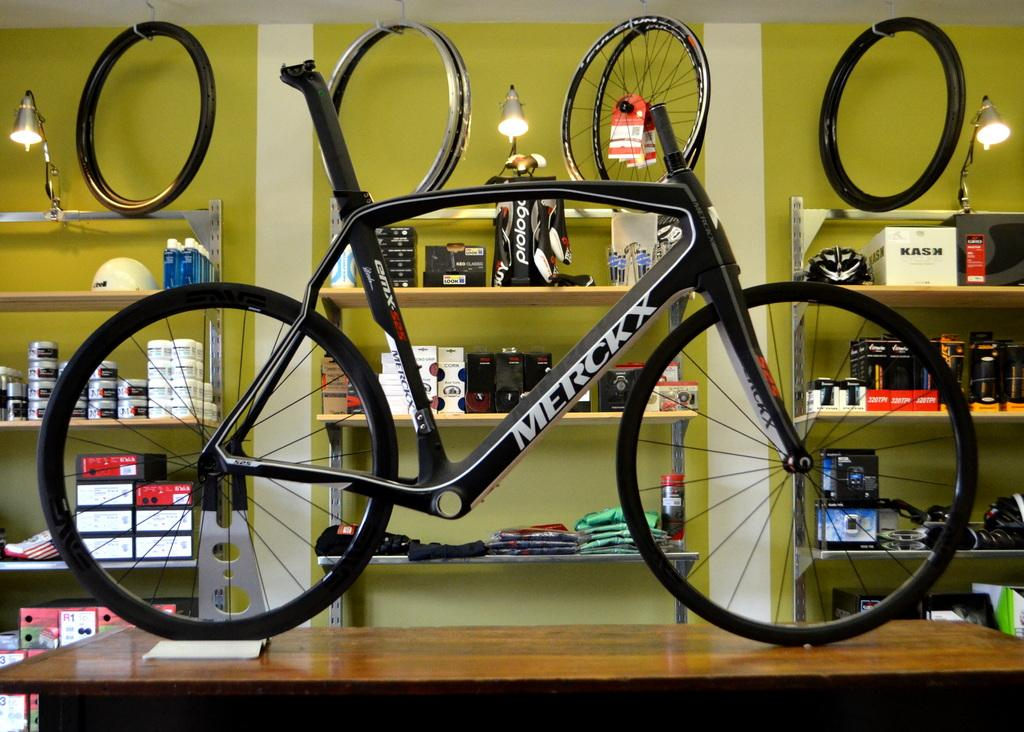What is placed on the table in the image? There is a bicycle on the table. What can be seen in the background of the image? There are shelves in the background of the image. What is present on the shelves? There are objects visible on the shelves. What type of cough medicine is visible on the shelves in the image? There is no cough medicine present in the image; the shelves contain objects, but no specific items are mentioned. 